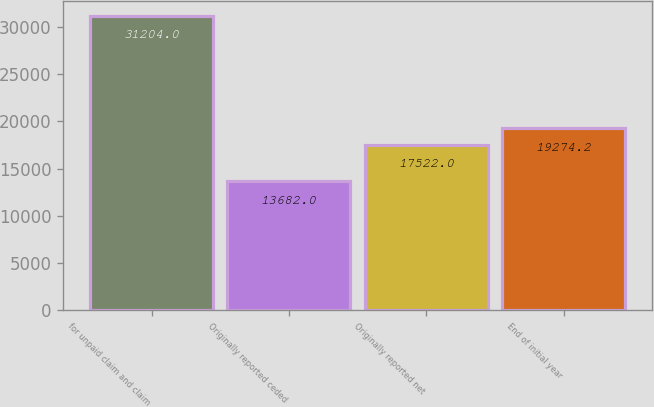Convert chart. <chart><loc_0><loc_0><loc_500><loc_500><bar_chart><fcel>for unpaid claim and claim<fcel>Originally reported ceded<fcel>Originally reported net<fcel>End of initial year<nl><fcel>31204<fcel>13682<fcel>17522<fcel>19274.2<nl></chart> 